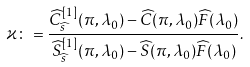Convert formula to latex. <formula><loc_0><loc_0><loc_500><loc_500>\varkappa \colon = \frac { \widehat { C } ^ { [ 1 ] } _ { \widehat { s } } ( \pi , \lambda _ { 0 } ) - \widehat { C } ( \pi , \lambda _ { 0 } ) \widehat { F } ( \lambda _ { 0 } ) } { \widehat { S } ^ { [ 1 ] } _ { \widehat { s } } ( \pi , \lambda _ { 0 } ) - \widehat { S } ( \pi , \lambda _ { 0 } ) \widehat { F } ( \lambda _ { 0 } ) } .</formula> 